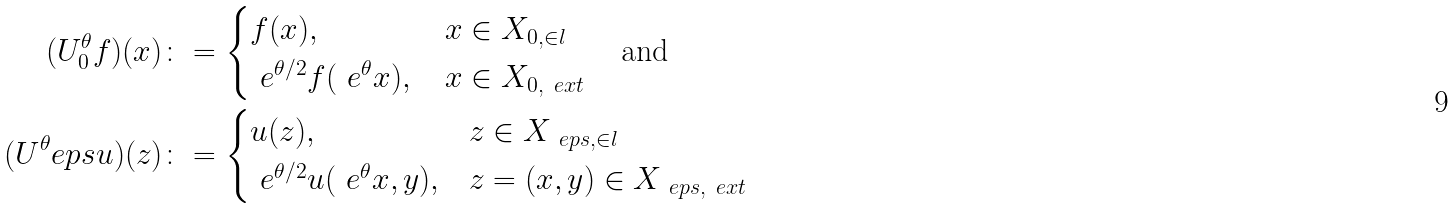Convert formula to latex. <formula><loc_0><loc_0><loc_500><loc_500>( U ^ { \theta } _ { 0 } f ) ( x ) & \colon = \begin{cases} f ( x ) , & \, x \in X _ { 0 , \in l } \\ \ e ^ { \theta / 2 } f ( \ e ^ { \theta } x ) , & \, x \in X _ { 0 , \ e x t } \end{cases} \quad \text {and} \\ ( U ^ { \theta } _ { \ } e p s u ) ( z ) & \colon = \begin{cases} u ( z ) , & z \in X _ { \ e p s , \in l } \\ \ e ^ { \theta / 2 } u ( \ e ^ { \theta } x , y ) , & z = ( x , y ) \in X _ { \ e p s , \ e x t } \end{cases}</formula> 